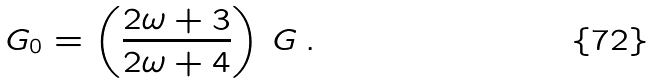<formula> <loc_0><loc_0><loc_500><loc_500>G _ { 0 } = \left ( \frac { 2 \omega + 3 } { 2 \omega + 4 } \right ) \, G \, .</formula> 